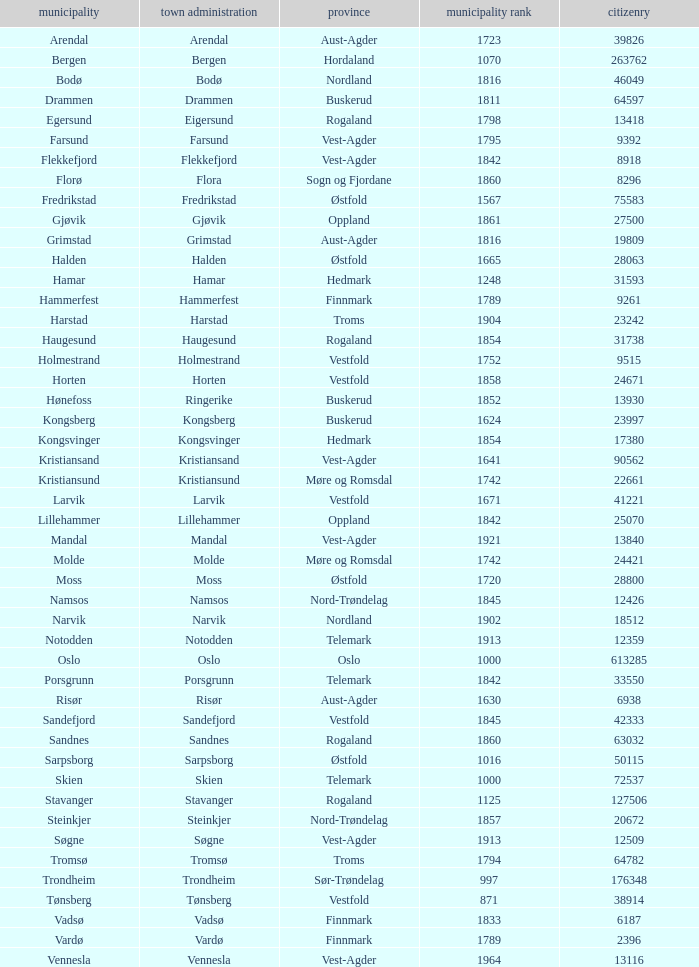What is the total population in the city/town of Arendal? 1.0. 